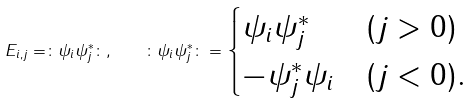Convert formula to latex. <formula><loc_0><loc_0><loc_500><loc_500>E _ { i , j } = \colon \psi _ { i } \psi _ { j } ^ { * } \colon , \quad \colon \psi _ { i } \psi _ { j } ^ { * } \colon = \begin{cases} \psi _ { i } \psi _ { j } ^ { * } & ( j > 0 ) \\ - \psi _ { j } ^ { * } \psi _ { i } & ( j < 0 ) . \end{cases}</formula> 